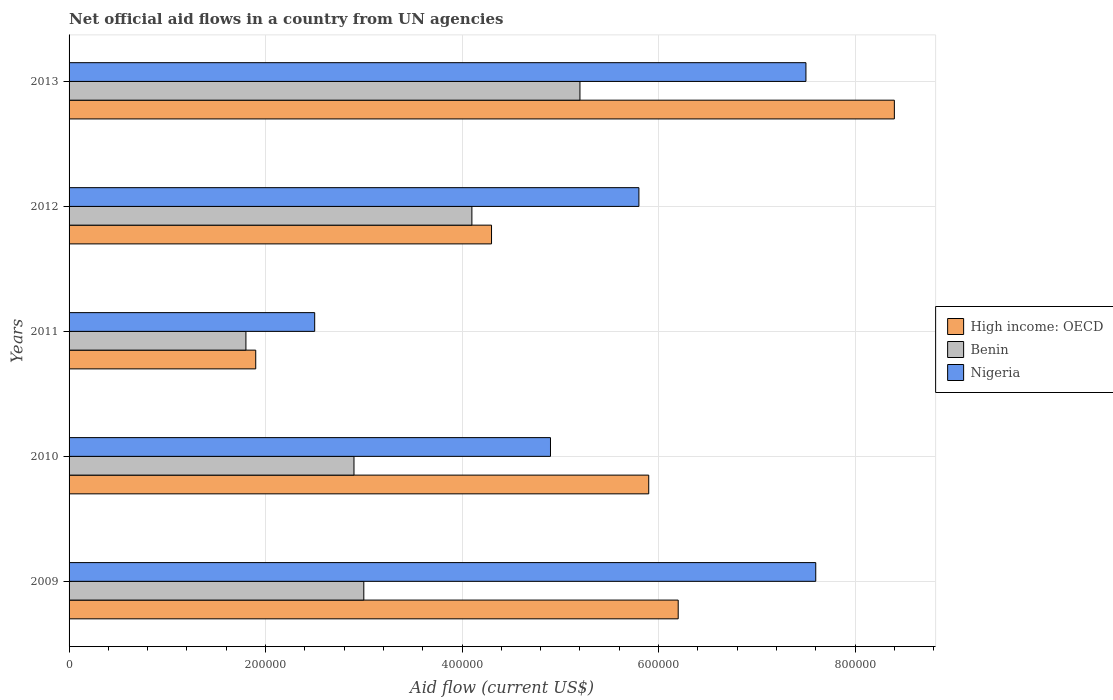Are the number of bars per tick equal to the number of legend labels?
Your response must be concise. Yes. Are the number of bars on each tick of the Y-axis equal?
Your answer should be very brief. Yes. How many bars are there on the 2nd tick from the top?
Make the answer very short. 3. What is the net official aid flow in Benin in 2013?
Ensure brevity in your answer.  5.20e+05. Across all years, what is the maximum net official aid flow in High income: OECD?
Ensure brevity in your answer.  8.40e+05. Across all years, what is the minimum net official aid flow in Nigeria?
Make the answer very short. 2.50e+05. In which year was the net official aid flow in Nigeria maximum?
Ensure brevity in your answer.  2009. In which year was the net official aid flow in Benin minimum?
Offer a very short reply. 2011. What is the total net official aid flow in Nigeria in the graph?
Your answer should be compact. 2.83e+06. What is the difference between the net official aid flow in Nigeria in 2009 and that in 2012?
Make the answer very short. 1.80e+05. What is the difference between the net official aid flow in Benin in 2010 and the net official aid flow in High income: OECD in 2013?
Provide a succinct answer. -5.50e+05. What is the average net official aid flow in Benin per year?
Keep it short and to the point. 3.40e+05. In the year 2009, what is the difference between the net official aid flow in High income: OECD and net official aid flow in Nigeria?
Ensure brevity in your answer.  -1.40e+05. In how many years, is the net official aid flow in Benin greater than 520000 US$?
Your answer should be compact. 0. What is the ratio of the net official aid flow in High income: OECD in 2011 to that in 2012?
Provide a short and direct response. 0.44. Is the net official aid flow in Nigeria in 2009 less than that in 2011?
Offer a very short reply. No. What is the difference between the highest and the second highest net official aid flow in Benin?
Offer a very short reply. 1.10e+05. What is the difference between the highest and the lowest net official aid flow in High income: OECD?
Provide a succinct answer. 6.50e+05. What does the 2nd bar from the top in 2011 represents?
Give a very brief answer. Benin. What does the 3rd bar from the bottom in 2013 represents?
Keep it short and to the point. Nigeria. How many bars are there?
Your answer should be very brief. 15. How many years are there in the graph?
Make the answer very short. 5. Are the values on the major ticks of X-axis written in scientific E-notation?
Offer a terse response. No. Does the graph contain grids?
Offer a very short reply. Yes. Where does the legend appear in the graph?
Ensure brevity in your answer.  Center right. How many legend labels are there?
Your answer should be compact. 3. What is the title of the graph?
Make the answer very short. Net official aid flows in a country from UN agencies. What is the label or title of the X-axis?
Keep it short and to the point. Aid flow (current US$). What is the label or title of the Y-axis?
Offer a terse response. Years. What is the Aid flow (current US$) of High income: OECD in 2009?
Make the answer very short. 6.20e+05. What is the Aid flow (current US$) in Benin in 2009?
Offer a very short reply. 3.00e+05. What is the Aid flow (current US$) in Nigeria in 2009?
Make the answer very short. 7.60e+05. What is the Aid flow (current US$) in High income: OECD in 2010?
Your answer should be compact. 5.90e+05. What is the Aid flow (current US$) of Benin in 2010?
Provide a short and direct response. 2.90e+05. What is the Aid flow (current US$) in Nigeria in 2010?
Your answer should be very brief. 4.90e+05. What is the Aid flow (current US$) of High income: OECD in 2011?
Ensure brevity in your answer.  1.90e+05. What is the Aid flow (current US$) of High income: OECD in 2012?
Your answer should be very brief. 4.30e+05. What is the Aid flow (current US$) in Benin in 2012?
Provide a succinct answer. 4.10e+05. What is the Aid flow (current US$) in Nigeria in 2012?
Offer a very short reply. 5.80e+05. What is the Aid flow (current US$) in High income: OECD in 2013?
Keep it short and to the point. 8.40e+05. What is the Aid flow (current US$) of Benin in 2013?
Offer a very short reply. 5.20e+05. What is the Aid flow (current US$) of Nigeria in 2013?
Make the answer very short. 7.50e+05. Across all years, what is the maximum Aid flow (current US$) of High income: OECD?
Offer a terse response. 8.40e+05. Across all years, what is the maximum Aid flow (current US$) of Benin?
Offer a terse response. 5.20e+05. Across all years, what is the maximum Aid flow (current US$) in Nigeria?
Provide a succinct answer. 7.60e+05. Across all years, what is the minimum Aid flow (current US$) in Benin?
Provide a short and direct response. 1.80e+05. Across all years, what is the minimum Aid flow (current US$) of Nigeria?
Ensure brevity in your answer.  2.50e+05. What is the total Aid flow (current US$) of High income: OECD in the graph?
Your response must be concise. 2.67e+06. What is the total Aid flow (current US$) of Benin in the graph?
Provide a short and direct response. 1.70e+06. What is the total Aid flow (current US$) in Nigeria in the graph?
Ensure brevity in your answer.  2.83e+06. What is the difference between the Aid flow (current US$) in Benin in 2009 and that in 2010?
Ensure brevity in your answer.  10000. What is the difference between the Aid flow (current US$) of Benin in 2009 and that in 2011?
Ensure brevity in your answer.  1.20e+05. What is the difference between the Aid flow (current US$) in Nigeria in 2009 and that in 2011?
Offer a very short reply. 5.10e+05. What is the difference between the Aid flow (current US$) in High income: OECD in 2009 and that in 2013?
Your answer should be very brief. -2.20e+05. What is the difference between the Aid flow (current US$) of Benin in 2009 and that in 2013?
Keep it short and to the point. -2.20e+05. What is the difference between the Aid flow (current US$) of Nigeria in 2010 and that in 2011?
Keep it short and to the point. 2.40e+05. What is the difference between the Aid flow (current US$) of High income: OECD in 2010 and that in 2012?
Provide a short and direct response. 1.60e+05. What is the difference between the Aid flow (current US$) in Benin in 2010 and that in 2012?
Offer a terse response. -1.20e+05. What is the difference between the Aid flow (current US$) in Nigeria in 2010 and that in 2012?
Keep it short and to the point. -9.00e+04. What is the difference between the Aid flow (current US$) of High income: OECD in 2010 and that in 2013?
Offer a very short reply. -2.50e+05. What is the difference between the Aid flow (current US$) of Benin in 2010 and that in 2013?
Offer a terse response. -2.30e+05. What is the difference between the Aid flow (current US$) in Nigeria in 2010 and that in 2013?
Make the answer very short. -2.60e+05. What is the difference between the Aid flow (current US$) of High income: OECD in 2011 and that in 2012?
Give a very brief answer. -2.40e+05. What is the difference between the Aid flow (current US$) of Benin in 2011 and that in 2012?
Ensure brevity in your answer.  -2.30e+05. What is the difference between the Aid flow (current US$) in Nigeria in 2011 and that in 2012?
Keep it short and to the point. -3.30e+05. What is the difference between the Aid flow (current US$) in High income: OECD in 2011 and that in 2013?
Your answer should be very brief. -6.50e+05. What is the difference between the Aid flow (current US$) of Benin in 2011 and that in 2013?
Provide a short and direct response. -3.40e+05. What is the difference between the Aid flow (current US$) of Nigeria in 2011 and that in 2013?
Ensure brevity in your answer.  -5.00e+05. What is the difference between the Aid flow (current US$) in High income: OECD in 2012 and that in 2013?
Keep it short and to the point. -4.10e+05. What is the difference between the Aid flow (current US$) in Nigeria in 2012 and that in 2013?
Make the answer very short. -1.70e+05. What is the difference between the Aid flow (current US$) of High income: OECD in 2009 and the Aid flow (current US$) of Nigeria in 2010?
Offer a very short reply. 1.30e+05. What is the difference between the Aid flow (current US$) in Benin in 2009 and the Aid flow (current US$) in Nigeria in 2010?
Your response must be concise. -1.90e+05. What is the difference between the Aid flow (current US$) in High income: OECD in 2009 and the Aid flow (current US$) in Benin in 2011?
Ensure brevity in your answer.  4.40e+05. What is the difference between the Aid flow (current US$) in High income: OECD in 2009 and the Aid flow (current US$) in Nigeria in 2012?
Make the answer very short. 4.00e+04. What is the difference between the Aid flow (current US$) of Benin in 2009 and the Aid flow (current US$) of Nigeria in 2012?
Keep it short and to the point. -2.80e+05. What is the difference between the Aid flow (current US$) in High income: OECD in 2009 and the Aid flow (current US$) in Benin in 2013?
Give a very brief answer. 1.00e+05. What is the difference between the Aid flow (current US$) of High income: OECD in 2009 and the Aid flow (current US$) of Nigeria in 2013?
Provide a short and direct response. -1.30e+05. What is the difference between the Aid flow (current US$) in Benin in 2009 and the Aid flow (current US$) in Nigeria in 2013?
Offer a very short reply. -4.50e+05. What is the difference between the Aid flow (current US$) of High income: OECD in 2010 and the Aid flow (current US$) of Benin in 2011?
Provide a succinct answer. 4.10e+05. What is the difference between the Aid flow (current US$) in Benin in 2010 and the Aid flow (current US$) in Nigeria in 2011?
Offer a very short reply. 4.00e+04. What is the difference between the Aid flow (current US$) in High income: OECD in 2010 and the Aid flow (current US$) in Nigeria in 2012?
Provide a succinct answer. 10000. What is the difference between the Aid flow (current US$) in Benin in 2010 and the Aid flow (current US$) in Nigeria in 2012?
Your response must be concise. -2.90e+05. What is the difference between the Aid flow (current US$) in High income: OECD in 2010 and the Aid flow (current US$) in Benin in 2013?
Offer a very short reply. 7.00e+04. What is the difference between the Aid flow (current US$) in Benin in 2010 and the Aid flow (current US$) in Nigeria in 2013?
Offer a terse response. -4.60e+05. What is the difference between the Aid flow (current US$) in High income: OECD in 2011 and the Aid flow (current US$) in Benin in 2012?
Offer a very short reply. -2.20e+05. What is the difference between the Aid flow (current US$) in High income: OECD in 2011 and the Aid flow (current US$) in Nigeria in 2012?
Your response must be concise. -3.90e+05. What is the difference between the Aid flow (current US$) of Benin in 2011 and the Aid flow (current US$) of Nigeria in 2012?
Give a very brief answer. -4.00e+05. What is the difference between the Aid flow (current US$) of High income: OECD in 2011 and the Aid flow (current US$) of Benin in 2013?
Provide a short and direct response. -3.30e+05. What is the difference between the Aid flow (current US$) of High income: OECD in 2011 and the Aid flow (current US$) of Nigeria in 2013?
Offer a very short reply. -5.60e+05. What is the difference between the Aid flow (current US$) in Benin in 2011 and the Aid flow (current US$) in Nigeria in 2013?
Provide a succinct answer. -5.70e+05. What is the difference between the Aid flow (current US$) in High income: OECD in 2012 and the Aid flow (current US$) in Nigeria in 2013?
Offer a terse response. -3.20e+05. What is the average Aid flow (current US$) in High income: OECD per year?
Your answer should be compact. 5.34e+05. What is the average Aid flow (current US$) in Benin per year?
Your answer should be compact. 3.40e+05. What is the average Aid flow (current US$) of Nigeria per year?
Offer a very short reply. 5.66e+05. In the year 2009, what is the difference between the Aid flow (current US$) in High income: OECD and Aid flow (current US$) in Nigeria?
Ensure brevity in your answer.  -1.40e+05. In the year 2009, what is the difference between the Aid flow (current US$) of Benin and Aid flow (current US$) of Nigeria?
Provide a short and direct response. -4.60e+05. In the year 2010, what is the difference between the Aid flow (current US$) of High income: OECD and Aid flow (current US$) of Benin?
Your answer should be compact. 3.00e+05. In the year 2010, what is the difference between the Aid flow (current US$) in Benin and Aid flow (current US$) in Nigeria?
Your answer should be very brief. -2.00e+05. In the year 2011, what is the difference between the Aid flow (current US$) of High income: OECD and Aid flow (current US$) of Benin?
Your answer should be very brief. 10000. In the year 2011, what is the difference between the Aid flow (current US$) in Benin and Aid flow (current US$) in Nigeria?
Offer a very short reply. -7.00e+04. In the year 2013, what is the difference between the Aid flow (current US$) of High income: OECD and Aid flow (current US$) of Benin?
Your answer should be very brief. 3.20e+05. What is the ratio of the Aid flow (current US$) in High income: OECD in 2009 to that in 2010?
Offer a terse response. 1.05. What is the ratio of the Aid flow (current US$) in Benin in 2009 to that in 2010?
Offer a terse response. 1.03. What is the ratio of the Aid flow (current US$) in Nigeria in 2009 to that in 2010?
Provide a short and direct response. 1.55. What is the ratio of the Aid flow (current US$) in High income: OECD in 2009 to that in 2011?
Offer a terse response. 3.26. What is the ratio of the Aid flow (current US$) in Benin in 2009 to that in 2011?
Make the answer very short. 1.67. What is the ratio of the Aid flow (current US$) of Nigeria in 2009 to that in 2011?
Your response must be concise. 3.04. What is the ratio of the Aid flow (current US$) in High income: OECD in 2009 to that in 2012?
Offer a very short reply. 1.44. What is the ratio of the Aid flow (current US$) in Benin in 2009 to that in 2012?
Provide a succinct answer. 0.73. What is the ratio of the Aid flow (current US$) in Nigeria in 2009 to that in 2012?
Offer a very short reply. 1.31. What is the ratio of the Aid flow (current US$) of High income: OECD in 2009 to that in 2013?
Your response must be concise. 0.74. What is the ratio of the Aid flow (current US$) of Benin in 2009 to that in 2013?
Provide a short and direct response. 0.58. What is the ratio of the Aid flow (current US$) of Nigeria in 2009 to that in 2013?
Your answer should be very brief. 1.01. What is the ratio of the Aid flow (current US$) in High income: OECD in 2010 to that in 2011?
Your answer should be compact. 3.11. What is the ratio of the Aid flow (current US$) of Benin in 2010 to that in 2011?
Provide a short and direct response. 1.61. What is the ratio of the Aid flow (current US$) in Nigeria in 2010 to that in 2011?
Offer a very short reply. 1.96. What is the ratio of the Aid flow (current US$) of High income: OECD in 2010 to that in 2012?
Make the answer very short. 1.37. What is the ratio of the Aid flow (current US$) of Benin in 2010 to that in 2012?
Your response must be concise. 0.71. What is the ratio of the Aid flow (current US$) in Nigeria in 2010 to that in 2012?
Ensure brevity in your answer.  0.84. What is the ratio of the Aid flow (current US$) of High income: OECD in 2010 to that in 2013?
Provide a short and direct response. 0.7. What is the ratio of the Aid flow (current US$) of Benin in 2010 to that in 2013?
Ensure brevity in your answer.  0.56. What is the ratio of the Aid flow (current US$) of Nigeria in 2010 to that in 2013?
Offer a terse response. 0.65. What is the ratio of the Aid flow (current US$) of High income: OECD in 2011 to that in 2012?
Your response must be concise. 0.44. What is the ratio of the Aid flow (current US$) of Benin in 2011 to that in 2012?
Provide a short and direct response. 0.44. What is the ratio of the Aid flow (current US$) of Nigeria in 2011 to that in 2012?
Your response must be concise. 0.43. What is the ratio of the Aid flow (current US$) of High income: OECD in 2011 to that in 2013?
Ensure brevity in your answer.  0.23. What is the ratio of the Aid flow (current US$) in Benin in 2011 to that in 2013?
Your answer should be compact. 0.35. What is the ratio of the Aid flow (current US$) in Nigeria in 2011 to that in 2013?
Provide a succinct answer. 0.33. What is the ratio of the Aid flow (current US$) of High income: OECD in 2012 to that in 2013?
Provide a succinct answer. 0.51. What is the ratio of the Aid flow (current US$) of Benin in 2012 to that in 2013?
Offer a very short reply. 0.79. What is the ratio of the Aid flow (current US$) of Nigeria in 2012 to that in 2013?
Your response must be concise. 0.77. What is the difference between the highest and the second highest Aid flow (current US$) of High income: OECD?
Keep it short and to the point. 2.20e+05. What is the difference between the highest and the second highest Aid flow (current US$) in Benin?
Your answer should be compact. 1.10e+05. What is the difference between the highest and the second highest Aid flow (current US$) in Nigeria?
Give a very brief answer. 10000. What is the difference between the highest and the lowest Aid flow (current US$) of High income: OECD?
Provide a short and direct response. 6.50e+05. What is the difference between the highest and the lowest Aid flow (current US$) in Nigeria?
Your response must be concise. 5.10e+05. 